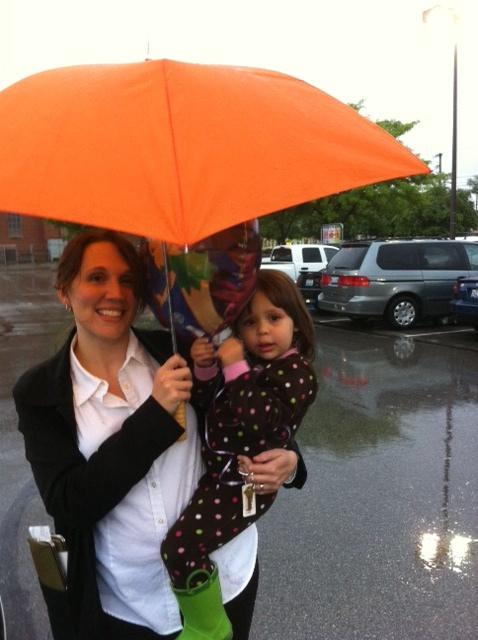Does the girl have stripes on her clothes?
Be succinct. No. Is it several colors?
Answer briefly. No. What is the little girl holding?
Be succinct. Balloon. What color is the umbrella?
Keep it brief. Orange. How many cars in picture?
Be succinct. 4. Why is the woman holding the umbrella?
Write a very short answer. Rain. Is it a sunny day?
Answer briefly. No. 